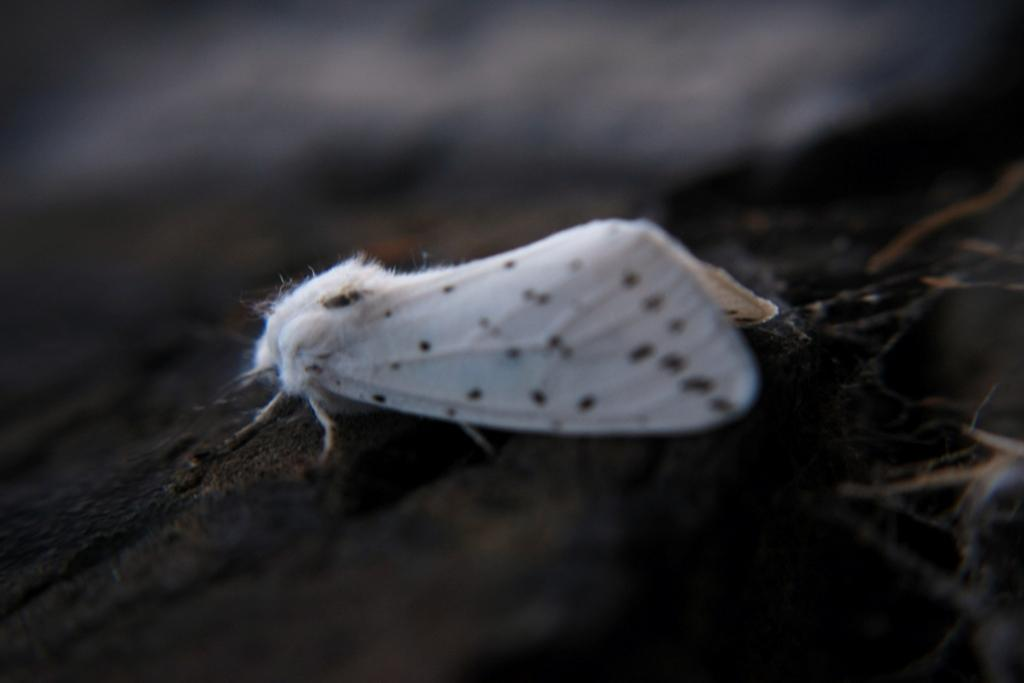What type of insect is visible in the image? There is a white color insect in the image. Can you describe the lighting conditions in the image? The image is dark. What type of structure can be seen in the image? There is no structure present in the image; it only features a white color insect. Can you tell me how many goats are visible in the image? There are no goats present in the image; it only features a white color insect. 